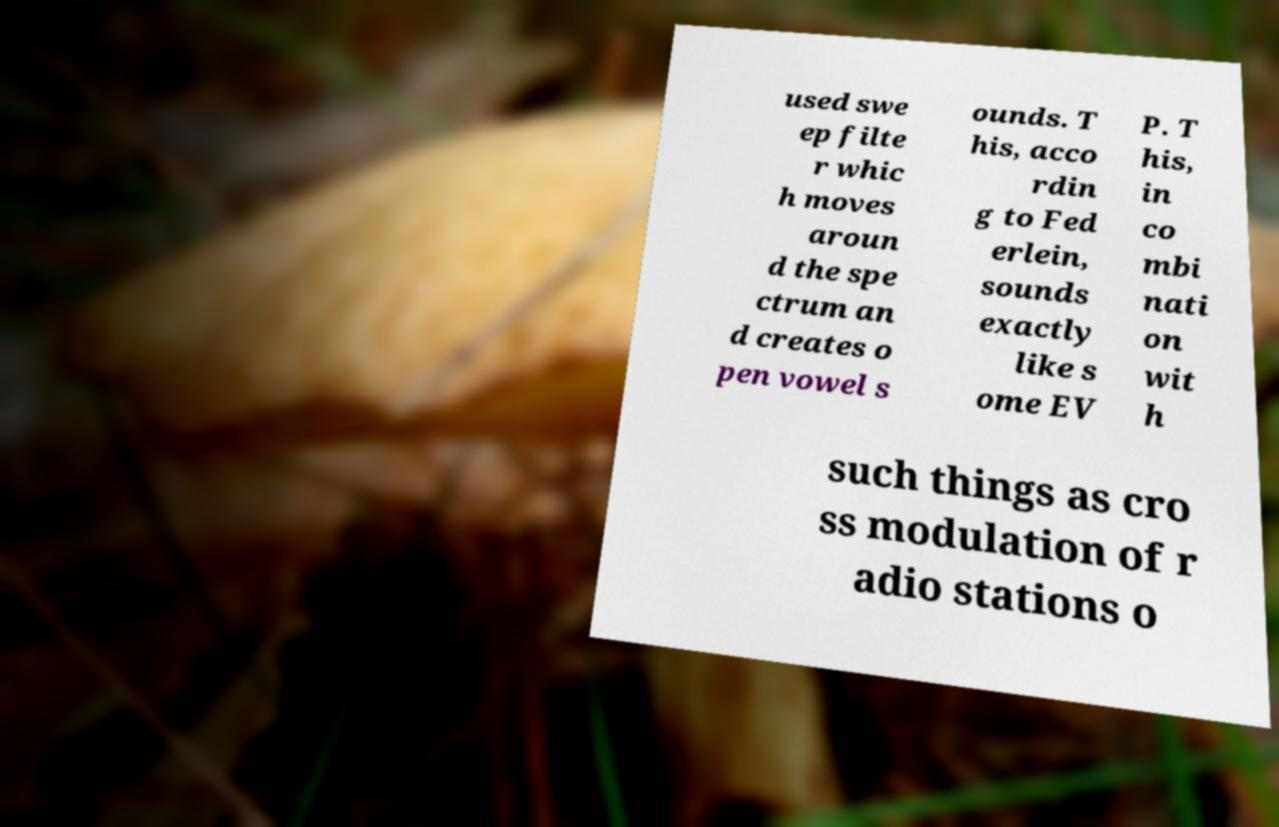There's text embedded in this image that I need extracted. Can you transcribe it verbatim? used swe ep filte r whic h moves aroun d the spe ctrum an d creates o pen vowel s ounds. T his, acco rdin g to Fed erlein, sounds exactly like s ome EV P. T his, in co mbi nati on wit h such things as cro ss modulation of r adio stations o 